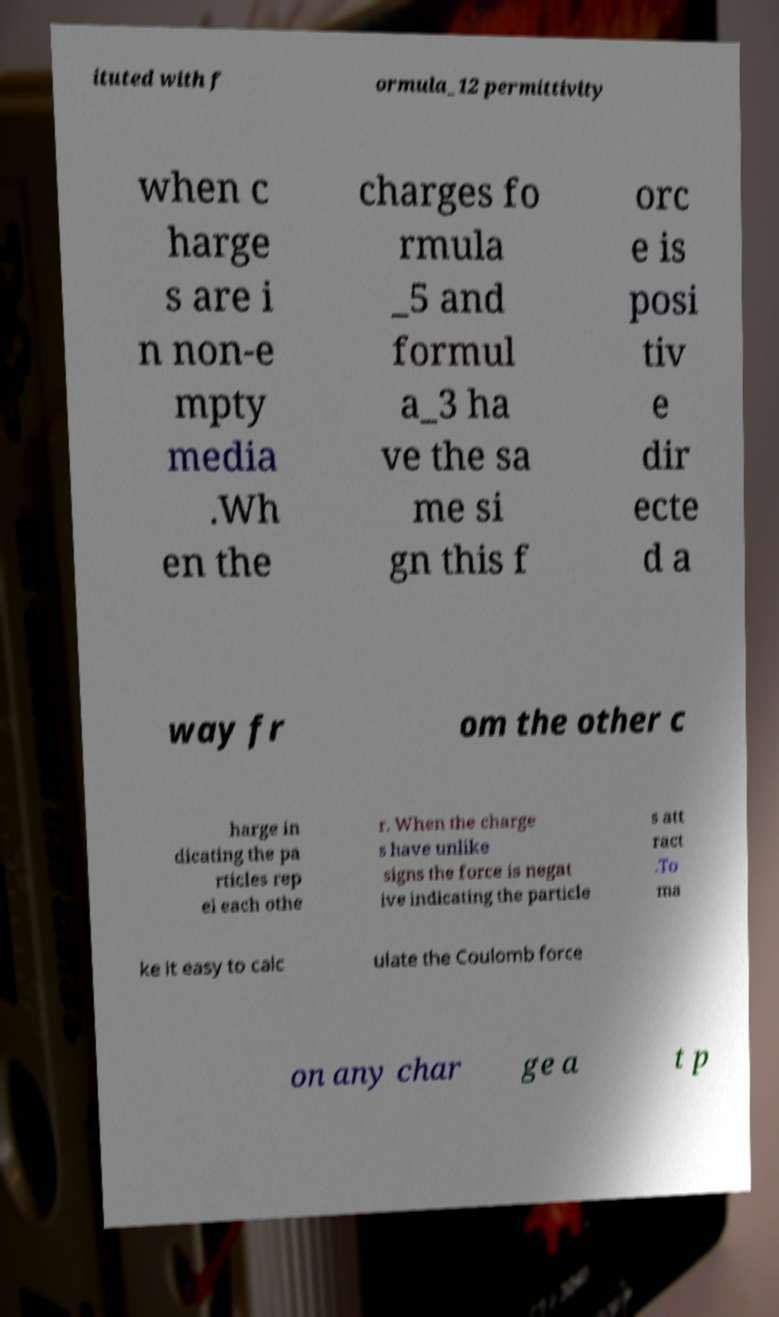Please identify and transcribe the text found in this image. ituted with f ormula_12 permittivity when c harge s are i n non-e mpty media .Wh en the charges fo rmula _5 and formul a_3 ha ve the sa me si gn this f orc e is posi tiv e dir ecte d a way fr om the other c harge in dicating the pa rticles rep el each othe r. When the charge s have unlike signs the force is negat ive indicating the particle s att ract .To ma ke it easy to calc ulate the Coulomb force on any char ge a t p 